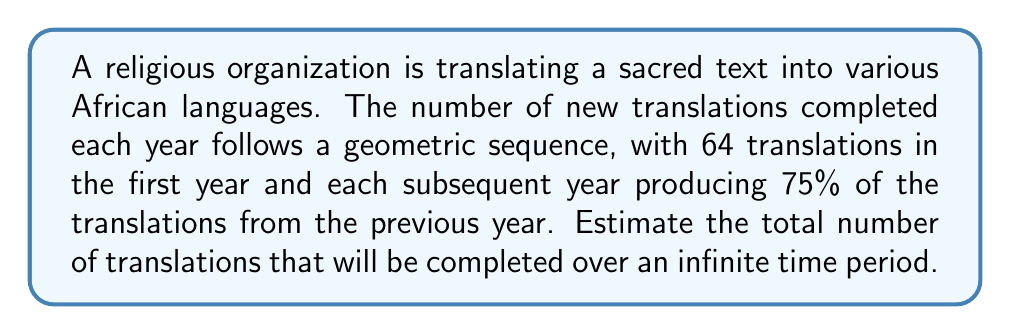Could you help me with this problem? Let's approach this step-by-step:

1) First, we need to identify the components of our geometric series:
   - First term, $a = 64$
   - Common ratio, $r = 0.75$

2) The sum of an infinite geometric series is given by the formula:
   $S_{\infty} = \frac{a}{1-r}$, where $|r| < 1$

3) In this case, $|r| = 0.75$, which is less than 1, so we can use this formula.

4) Substituting our values:
   $S_{\infty} = \frac{64}{1-0.75}$

5) Simplify:
   $S_{\infty} = \frac{64}{0.25} = 64 * 4 = 256$

Therefore, the estimated total number of translations over an infinite time period is 256.
Answer: 256 translations 